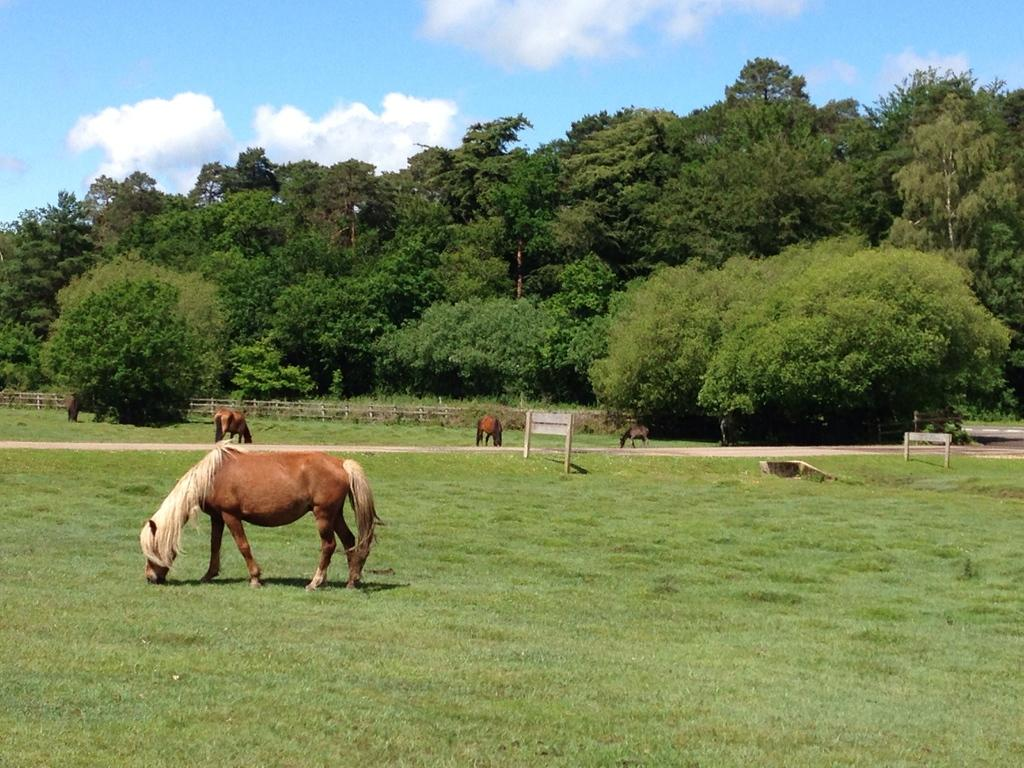What type of animals can be seen in the image? There are animals on the grassy land in the image. What is located behind the animals? There is a wooden fence behind the animals. What can be seen behind the wooden fence? There is a group of trees behind the wooden fence. What is visible at the top of the image? The sky is visible at the top of the image. Where is the patch of hair located in the image? There is no patch of hair present in the image. What type of tub can be seen in the image? There is no tub present in the image. 